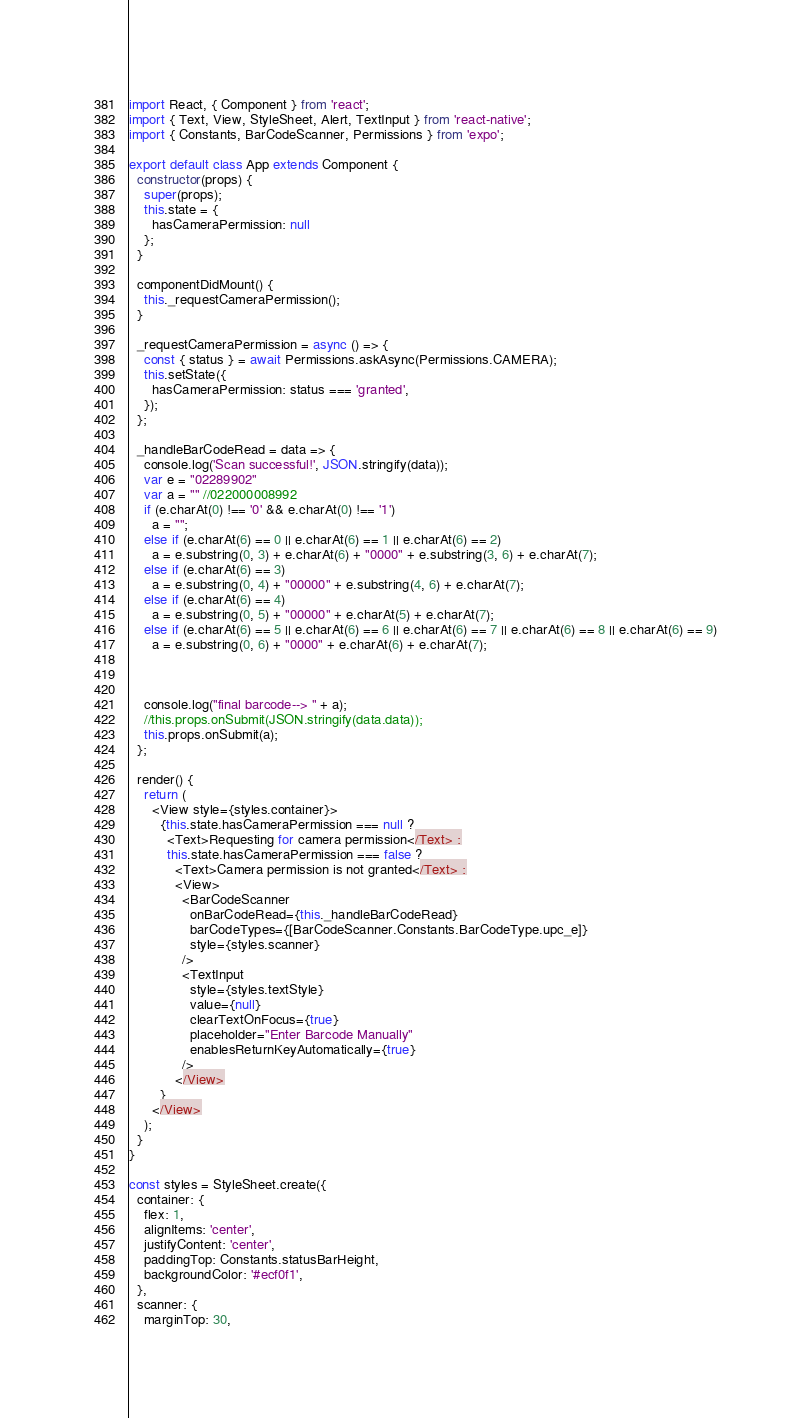Convert code to text. <code><loc_0><loc_0><loc_500><loc_500><_JavaScript_>import React, { Component } from 'react';
import { Text, View, StyleSheet, Alert, TextInput } from 'react-native';
import { Constants, BarCodeScanner, Permissions } from 'expo';

export default class App extends Component {
  constructor(props) {
    super(props);
    this.state = {
      hasCameraPermission: null
    };
  }

  componentDidMount() {
    this._requestCameraPermission();
  }

  _requestCameraPermission = async () => {
    const { status } = await Permissions.askAsync(Permissions.CAMERA);
    this.setState({
      hasCameraPermission: status === 'granted',
    });
  };

  _handleBarCodeRead = data => {
    console.log('Scan successful!', JSON.stringify(data));
    var e = "02289902"
    var a = "" //022000008992
    if (e.charAt(0) !== '0' && e.charAt(0) !== '1')
      a = "";
    else if (e.charAt(6) == 0 || e.charAt(6) == 1 || e.charAt(6) == 2)
      a = e.substring(0, 3) + e.charAt(6) + "0000" + e.substring(3, 6) + e.charAt(7);
    else if (e.charAt(6) == 3)
      a = e.substring(0, 4) + "00000" + e.substring(4, 6) + e.charAt(7);
    else if (e.charAt(6) == 4)
      a = e.substring(0, 5) + "00000" + e.charAt(5) + e.charAt(7);
    else if (e.charAt(6) == 5 || e.charAt(6) == 6 || e.charAt(6) == 7 || e.charAt(6) == 8 || e.charAt(6) == 9)
      a = e.substring(0, 6) + "0000" + e.charAt(6) + e.charAt(7);



    console.log("final barcode--> " + a);
    //this.props.onSubmit(JSON.stringify(data.data));
    this.props.onSubmit(a);
  };

  render() {
    return (
      <View style={styles.container}>
        {this.state.hasCameraPermission === null ?
          <Text>Requesting for camera permission</Text> :
          this.state.hasCameraPermission === false ?
            <Text>Camera permission is not granted</Text> :
            <View>
              <BarCodeScanner
                onBarCodeRead={this._handleBarCodeRead}
                barCodeTypes={[BarCodeScanner.Constants.BarCodeType.upc_e]}
                style={styles.scanner}
              />
              <TextInput
                style={styles.textStyle}
                value={null}
                clearTextOnFocus={true}
                placeholder="Enter Barcode Manually"
                enablesReturnKeyAutomatically={true}
              />
            </View>
        }
      </View>
    );
  }
}

const styles = StyleSheet.create({
  container: {
    flex: 1,
    alignItems: 'center',
    justifyContent: 'center',
    paddingTop: Constants.statusBarHeight,
    backgroundColor: '#ecf0f1',
  },
  scanner: {
    marginTop: 30,</code> 